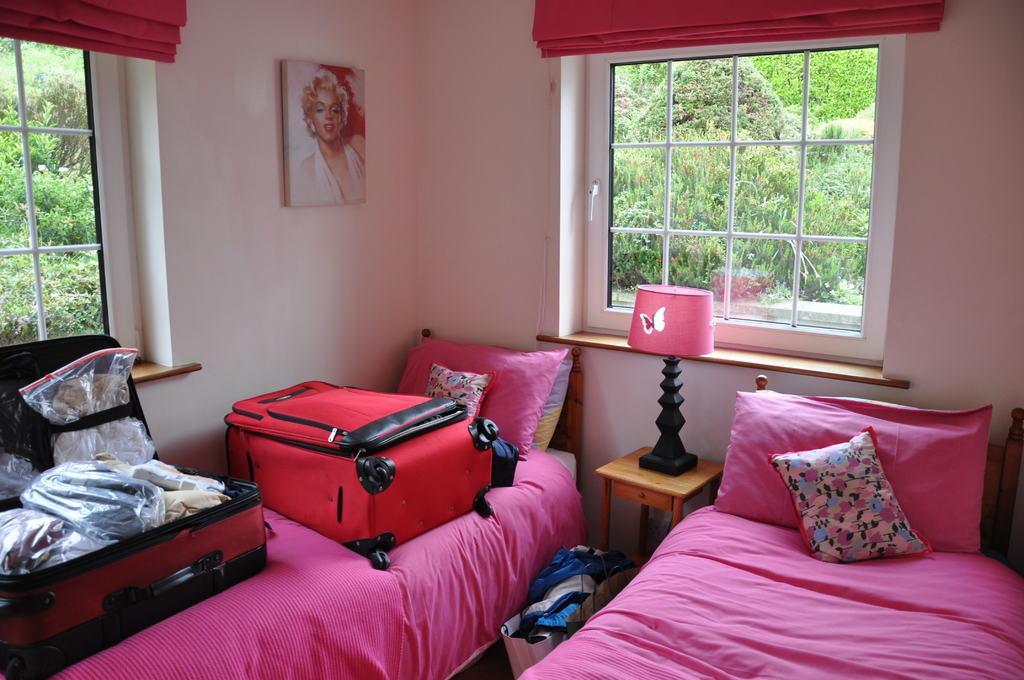Describe this image in one or two sentences. In the image we can see two beds. On bed we can see two trolleys,bed sheets,pillows. In between bed we can see table,lamp and one more bag. And back we can see wall,frame,window,trees,curtain etc. 